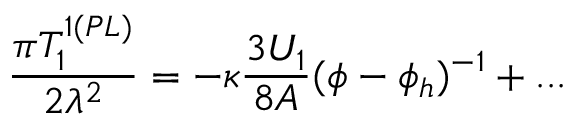Convert formula to latex. <formula><loc_0><loc_0><loc_500><loc_500>\frac { \pi T _ { 1 } ^ { 1 ( P L ) } } { 2 \lambda ^ { 2 } } = - \kappa \frac { 3 U _ { 1 } } { 8 A } ( \phi - \phi _ { h } ) ^ { - 1 } + \dots</formula> 